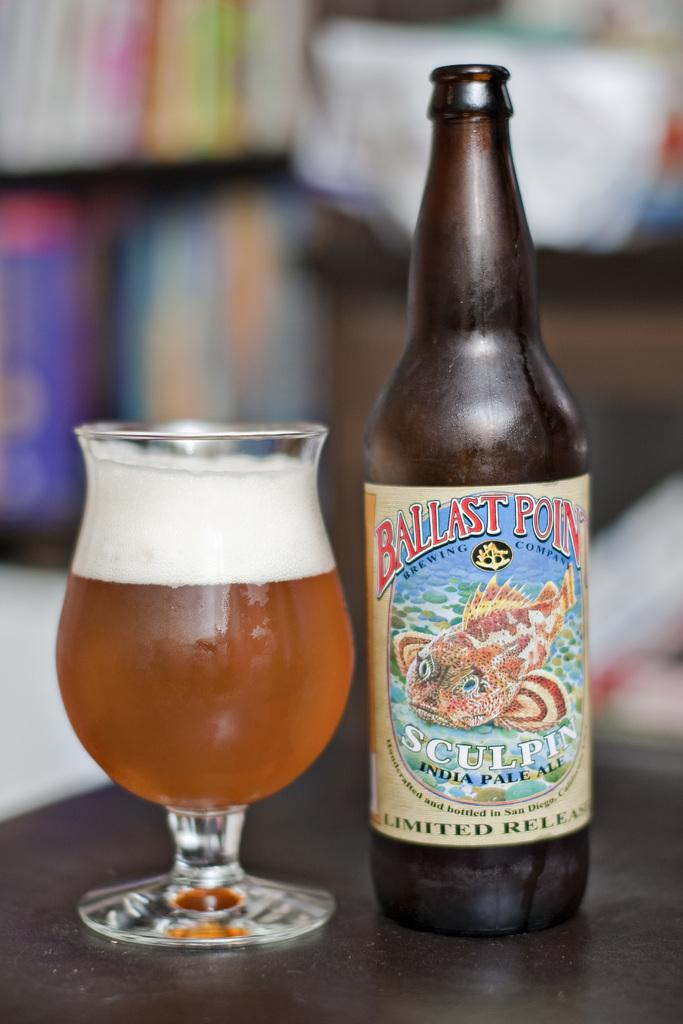<image>
Provide a brief description of the given image. A bottle of Ballast Point is next to a full glass. 